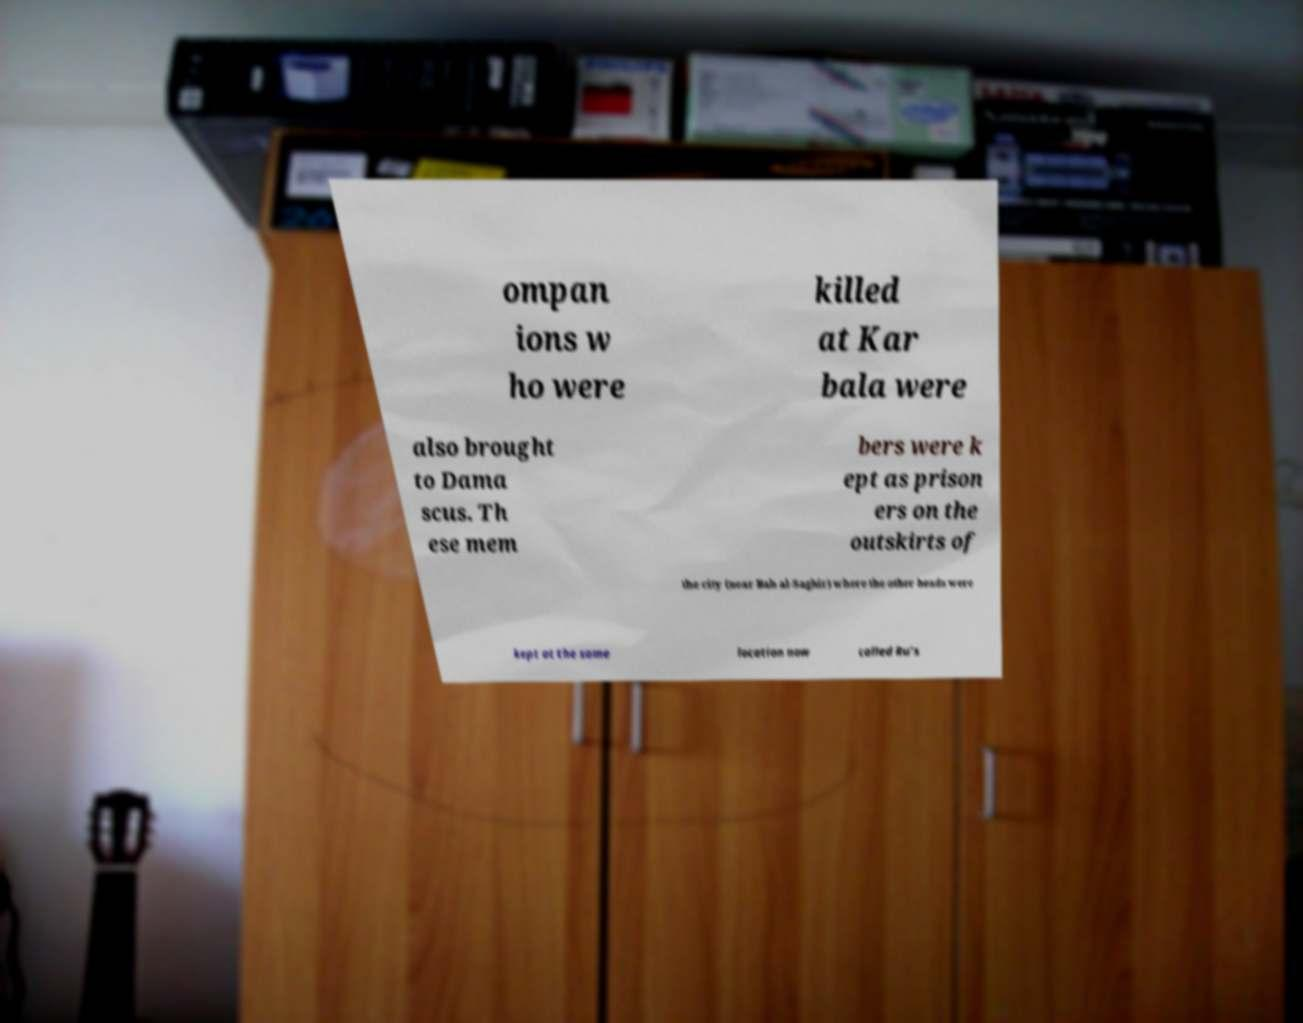I need the written content from this picture converted into text. Can you do that? ompan ions w ho were killed at Kar bala were also brought to Dama scus. Th ese mem bers were k ept as prison ers on the outskirts of the city (near Bab al-Saghir) where the other heads were kept at the same location now called Ru’s 